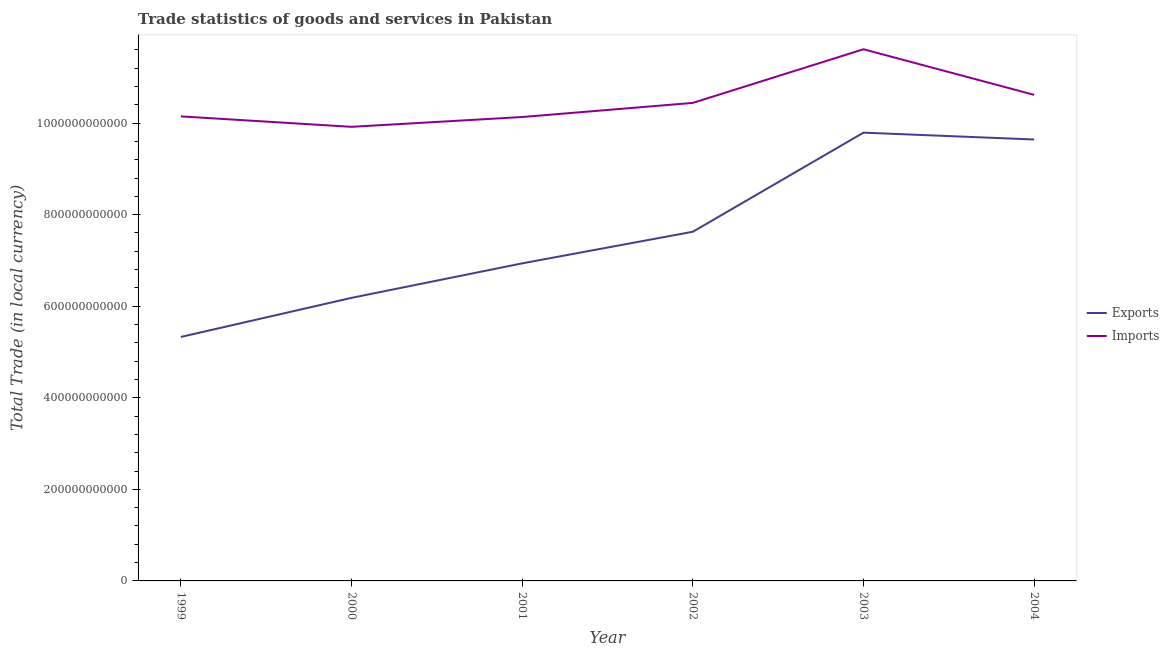How many different coloured lines are there?
Your response must be concise. 2. What is the export of goods and services in 1999?
Your answer should be very brief. 5.33e+11. Across all years, what is the maximum imports of goods and services?
Offer a very short reply. 1.16e+12. Across all years, what is the minimum imports of goods and services?
Your answer should be compact. 9.92e+11. What is the total export of goods and services in the graph?
Keep it short and to the point. 4.55e+12. What is the difference between the export of goods and services in 1999 and that in 2003?
Ensure brevity in your answer.  -4.46e+11. What is the difference between the export of goods and services in 2001 and the imports of goods and services in 2002?
Keep it short and to the point. -3.51e+11. What is the average export of goods and services per year?
Offer a terse response. 7.59e+11. In the year 2002, what is the difference between the imports of goods and services and export of goods and services?
Make the answer very short. 2.81e+11. In how many years, is the export of goods and services greater than 240000000000 LCU?
Make the answer very short. 6. What is the ratio of the export of goods and services in 1999 to that in 2001?
Offer a very short reply. 0.77. Is the imports of goods and services in 2001 less than that in 2002?
Ensure brevity in your answer.  Yes. What is the difference between the highest and the second highest export of goods and services?
Keep it short and to the point. 1.50e+1. What is the difference between the highest and the lowest export of goods and services?
Offer a terse response. 4.46e+11. In how many years, is the export of goods and services greater than the average export of goods and services taken over all years?
Keep it short and to the point. 3. Does the imports of goods and services monotonically increase over the years?
Your answer should be compact. No. Is the export of goods and services strictly greater than the imports of goods and services over the years?
Ensure brevity in your answer.  No. Is the imports of goods and services strictly less than the export of goods and services over the years?
Give a very brief answer. No. How many lines are there?
Offer a very short reply. 2. How many years are there in the graph?
Provide a succinct answer. 6. What is the difference between two consecutive major ticks on the Y-axis?
Your answer should be compact. 2.00e+11. Are the values on the major ticks of Y-axis written in scientific E-notation?
Offer a very short reply. No. Does the graph contain grids?
Provide a succinct answer. No. Where does the legend appear in the graph?
Offer a very short reply. Center right. How are the legend labels stacked?
Your answer should be compact. Vertical. What is the title of the graph?
Offer a very short reply. Trade statistics of goods and services in Pakistan. Does "Not attending school" appear as one of the legend labels in the graph?
Offer a very short reply. No. What is the label or title of the X-axis?
Keep it short and to the point. Year. What is the label or title of the Y-axis?
Provide a short and direct response. Total Trade (in local currency). What is the Total Trade (in local currency) in Exports in 1999?
Your response must be concise. 5.33e+11. What is the Total Trade (in local currency) in Imports in 1999?
Your response must be concise. 1.01e+12. What is the Total Trade (in local currency) of Exports in 2000?
Your response must be concise. 6.18e+11. What is the Total Trade (in local currency) of Imports in 2000?
Provide a short and direct response. 9.92e+11. What is the Total Trade (in local currency) of Exports in 2001?
Ensure brevity in your answer.  6.94e+11. What is the Total Trade (in local currency) of Imports in 2001?
Keep it short and to the point. 1.01e+12. What is the Total Trade (in local currency) of Exports in 2002?
Ensure brevity in your answer.  7.63e+11. What is the Total Trade (in local currency) of Imports in 2002?
Make the answer very short. 1.04e+12. What is the Total Trade (in local currency) in Exports in 2003?
Provide a succinct answer. 9.79e+11. What is the Total Trade (in local currency) of Imports in 2003?
Your response must be concise. 1.16e+12. What is the Total Trade (in local currency) of Exports in 2004?
Your response must be concise. 9.64e+11. What is the Total Trade (in local currency) in Imports in 2004?
Ensure brevity in your answer.  1.06e+12. Across all years, what is the maximum Total Trade (in local currency) in Exports?
Provide a short and direct response. 9.79e+11. Across all years, what is the maximum Total Trade (in local currency) in Imports?
Provide a short and direct response. 1.16e+12. Across all years, what is the minimum Total Trade (in local currency) in Exports?
Offer a very short reply. 5.33e+11. Across all years, what is the minimum Total Trade (in local currency) of Imports?
Make the answer very short. 9.92e+11. What is the total Total Trade (in local currency) of Exports in the graph?
Provide a short and direct response. 4.55e+12. What is the total Total Trade (in local currency) of Imports in the graph?
Your answer should be very brief. 6.29e+12. What is the difference between the Total Trade (in local currency) of Exports in 1999 and that in 2000?
Provide a short and direct response. -8.54e+1. What is the difference between the Total Trade (in local currency) in Imports in 1999 and that in 2000?
Offer a very short reply. 2.28e+1. What is the difference between the Total Trade (in local currency) in Exports in 1999 and that in 2001?
Your response must be concise. -1.61e+11. What is the difference between the Total Trade (in local currency) of Imports in 1999 and that in 2001?
Offer a very short reply. 1.41e+09. What is the difference between the Total Trade (in local currency) of Exports in 1999 and that in 2002?
Make the answer very short. -2.30e+11. What is the difference between the Total Trade (in local currency) in Imports in 1999 and that in 2002?
Provide a succinct answer. -2.94e+1. What is the difference between the Total Trade (in local currency) in Exports in 1999 and that in 2003?
Ensure brevity in your answer.  -4.46e+11. What is the difference between the Total Trade (in local currency) in Imports in 1999 and that in 2003?
Provide a succinct answer. -1.47e+11. What is the difference between the Total Trade (in local currency) of Exports in 1999 and that in 2004?
Keep it short and to the point. -4.31e+11. What is the difference between the Total Trade (in local currency) in Imports in 1999 and that in 2004?
Make the answer very short. -4.70e+1. What is the difference between the Total Trade (in local currency) in Exports in 2000 and that in 2001?
Provide a short and direct response. -7.53e+1. What is the difference between the Total Trade (in local currency) in Imports in 2000 and that in 2001?
Make the answer very short. -2.14e+1. What is the difference between the Total Trade (in local currency) of Exports in 2000 and that in 2002?
Make the answer very short. -1.44e+11. What is the difference between the Total Trade (in local currency) in Imports in 2000 and that in 2002?
Provide a short and direct response. -5.23e+1. What is the difference between the Total Trade (in local currency) of Exports in 2000 and that in 2003?
Your answer should be very brief. -3.61e+11. What is the difference between the Total Trade (in local currency) of Imports in 2000 and that in 2003?
Your response must be concise. -1.69e+11. What is the difference between the Total Trade (in local currency) of Exports in 2000 and that in 2004?
Your answer should be very brief. -3.46e+11. What is the difference between the Total Trade (in local currency) of Imports in 2000 and that in 2004?
Ensure brevity in your answer.  -6.98e+1. What is the difference between the Total Trade (in local currency) of Exports in 2001 and that in 2002?
Provide a short and direct response. -6.91e+1. What is the difference between the Total Trade (in local currency) in Imports in 2001 and that in 2002?
Your answer should be very brief. -3.08e+1. What is the difference between the Total Trade (in local currency) of Exports in 2001 and that in 2003?
Provide a succinct answer. -2.86e+11. What is the difference between the Total Trade (in local currency) in Imports in 2001 and that in 2003?
Give a very brief answer. -1.48e+11. What is the difference between the Total Trade (in local currency) of Exports in 2001 and that in 2004?
Provide a short and direct response. -2.71e+11. What is the difference between the Total Trade (in local currency) in Imports in 2001 and that in 2004?
Offer a very short reply. -4.84e+1. What is the difference between the Total Trade (in local currency) in Exports in 2002 and that in 2003?
Provide a succinct answer. -2.16e+11. What is the difference between the Total Trade (in local currency) of Imports in 2002 and that in 2003?
Your answer should be compact. -1.17e+11. What is the difference between the Total Trade (in local currency) in Exports in 2002 and that in 2004?
Ensure brevity in your answer.  -2.01e+11. What is the difference between the Total Trade (in local currency) in Imports in 2002 and that in 2004?
Ensure brevity in your answer.  -1.76e+1. What is the difference between the Total Trade (in local currency) of Exports in 2003 and that in 2004?
Provide a succinct answer. 1.50e+1. What is the difference between the Total Trade (in local currency) of Imports in 2003 and that in 2004?
Make the answer very short. 9.96e+1. What is the difference between the Total Trade (in local currency) of Exports in 1999 and the Total Trade (in local currency) of Imports in 2000?
Provide a short and direct response. -4.59e+11. What is the difference between the Total Trade (in local currency) of Exports in 1999 and the Total Trade (in local currency) of Imports in 2001?
Your response must be concise. -4.80e+11. What is the difference between the Total Trade (in local currency) of Exports in 1999 and the Total Trade (in local currency) of Imports in 2002?
Offer a terse response. -5.11e+11. What is the difference between the Total Trade (in local currency) of Exports in 1999 and the Total Trade (in local currency) of Imports in 2003?
Your answer should be very brief. -6.28e+11. What is the difference between the Total Trade (in local currency) in Exports in 1999 and the Total Trade (in local currency) in Imports in 2004?
Make the answer very short. -5.29e+11. What is the difference between the Total Trade (in local currency) in Exports in 2000 and the Total Trade (in local currency) in Imports in 2001?
Your response must be concise. -3.95e+11. What is the difference between the Total Trade (in local currency) in Exports in 2000 and the Total Trade (in local currency) in Imports in 2002?
Provide a succinct answer. -4.26e+11. What is the difference between the Total Trade (in local currency) in Exports in 2000 and the Total Trade (in local currency) in Imports in 2003?
Give a very brief answer. -5.43e+11. What is the difference between the Total Trade (in local currency) of Exports in 2000 and the Total Trade (in local currency) of Imports in 2004?
Provide a short and direct response. -4.43e+11. What is the difference between the Total Trade (in local currency) in Exports in 2001 and the Total Trade (in local currency) in Imports in 2002?
Ensure brevity in your answer.  -3.51e+11. What is the difference between the Total Trade (in local currency) of Exports in 2001 and the Total Trade (in local currency) of Imports in 2003?
Offer a very short reply. -4.68e+11. What is the difference between the Total Trade (in local currency) in Exports in 2001 and the Total Trade (in local currency) in Imports in 2004?
Your answer should be compact. -3.68e+11. What is the difference between the Total Trade (in local currency) of Exports in 2002 and the Total Trade (in local currency) of Imports in 2003?
Ensure brevity in your answer.  -3.99e+11. What is the difference between the Total Trade (in local currency) in Exports in 2002 and the Total Trade (in local currency) in Imports in 2004?
Give a very brief answer. -2.99e+11. What is the difference between the Total Trade (in local currency) of Exports in 2003 and the Total Trade (in local currency) of Imports in 2004?
Offer a very short reply. -8.26e+1. What is the average Total Trade (in local currency) in Exports per year?
Make the answer very short. 7.59e+11. What is the average Total Trade (in local currency) in Imports per year?
Offer a very short reply. 1.05e+12. In the year 1999, what is the difference between the Total Trade (in local currency) in Exports and Total Trade (in local currency) in Imports?
Provide a short and direct response. -4.82e+11. In the year 2000, what is the difference between the Total Trade (in local currency) of Exports and Total Trade (in local currency) of Imports?
Make the answer very short. -3.74e+11. In the year 2001, what is the difference between the Total Trade (in local currency) of Exports and Total Trade (in local currency) of Imports?
Keep it short and to the point. -3.20e+11. In the year 2002, what is the difference between the Total Trade (in local currency) of Exports and Total Trade (in local currency) of Imports?
Make the answer very short. -2.81e+11. In the year 2003, what is the difference between the Total Trade (in local currency) of Exports and Total Trade (in local currency) of Imports?
Provide a short and direct response. -1.82e+11. In the year 2004, what is the difference between the Total Trade (in local currency) in Exports and Total Trade (in local currency) in Imports?
Offer a very short reply. -9.75e+1. What is the ratio of the Total Trade (in local currency) of Exports in 1999 to that in 2000?
Provide a short and direct response. 0.86. What is the ratio of the Total Trade (in local currency) in Exports in 1999 to that in 2001?
Your answer should be compact. 0.77. What is the ratio of the Total Trade (in local currency) of Exports in 1999 to that in 2002?
Offer a terse response. 0.7. What is the ratio of the Total Trade (in local currency) in Imports in 1999 to that in 2002?
Provide a short and direct response. 0.97. What is the ratio of the Total Trade (in local currency) of Exports in 1999 to that in 2003?
Your answer should be compact. 0.54. What is the ratio of the Total Trade (in local currency) of Imports in 1999 to that in 2003?
Give a very brief answer. 0.87. What is the ratio of the Total Trade (in local currency) in Exports in 1999 to that in 2004?
Offer a terse response. 0.55. What is the ratio of the Total Trade (in local currency) in Imports in 1999 to that in 2004?
Offer a terse response. 0.96. What is the ratio of the Total Trade (in local currency) in Exports in 2000 to that in 2001?
Make the answer very short. 0.89. What is the ratio of the Total Trade (in local currency) in Imports in 2000 to that in 2001?
Provide a short and direct response. 0.98. What is the ratio of the Total Trade (in local currency) of Exports in 2000 to that in 2002?
Your answer should be very brief. 0.81. What is the ratio of the Total Trade (in local currency) of Imports in 2000 to that in 2002?
Your answer should be compact. 0.95. What is the ratio of the Total Trade (in local currency) of Exports in 2000 to that in 2003?
Offer a very short reply. 0.63. What is the ratio of the Total Trade (in local currency) in Imports in 2000 to that in 2003?
Provide a short and direct response. 0.85. What is the ratio of the Total Trade (in local currency) in Exports in 2000 to that in 2004?
Offer a terse response. 0.64. What is the ratio of the Total Trade (in local currency) of Imports in 2000 to that in 2004?
Offer a terse response. 0.93. What is the ratio of the Total Trade (in local currency) in Exports in 2001 to that in 2002?
Keep it short and to the point. 0.91. What is the ratio of the Total Trade (in local currency) of Imports in 2001 to that in 2002?
Your response must be concise. 0.97. What is the ratio of the Total Trade (in local currency) of Exports in 2001 to that in 2003?
Make the answer very short. 0.71. What is the ratio of the Total Trade (in local currency) of Imports in 2001 to that in 2003?
Ensure brevity in your answer.  0.87. What is the ratio of the Total Trade (in local currency) of Exports in 2001 to that in 2004?
Provide a short and direct response. 0.72. What is the ratio of the Total Trade (in local currency) of Imports in 2001 to that in 2004?
Provide a short and direct response. 0.95. What is the ratio of the Total Trade (in local currency) of Exports in 2002 to that in 2003?
Your response must be concise. 0.78. What is the ratio of the Total Trade (in local currency) in Imports in 2002 to that in 2003?
Provide a short and direct response. 0.9. What is the ratio of the Total Trade (in local currency) in Exports in 2002 to that in 2004?
Make the answer very short. 0.79. What is the ratio of the Total Trade (in local currency) in Imports in 2002 to that in 2004?
Your answer should be compact. 0.98. What is the ratio of the Total Trade (in local currency) of Exports in 2003 to that in 2004?
Ensure brevity in your answer.  1.02. What is the ratio of the Total Trade (in local currency) of Imports in 2003 to that in 2004?
Give a very brief answer. 1.09. What is the difference between the highest and the second highest Total Trade (in local currency) in Exports?
Provide a short and direct response. 1.50e+1. What is the difference between the highest and the second highest Total Trade (in local currency) in Imports?
Give a very brief answer. 9.96e+1. What is the difference between the highest and the lowest Total Trade (in local currency) in Exports?
Keep it short and to the point. 4.46e+11. What is the difference between the highest and the lowest Total Trade (in local currency) in Imports?
Ensure brevity in your answer.  1.69e+11. 